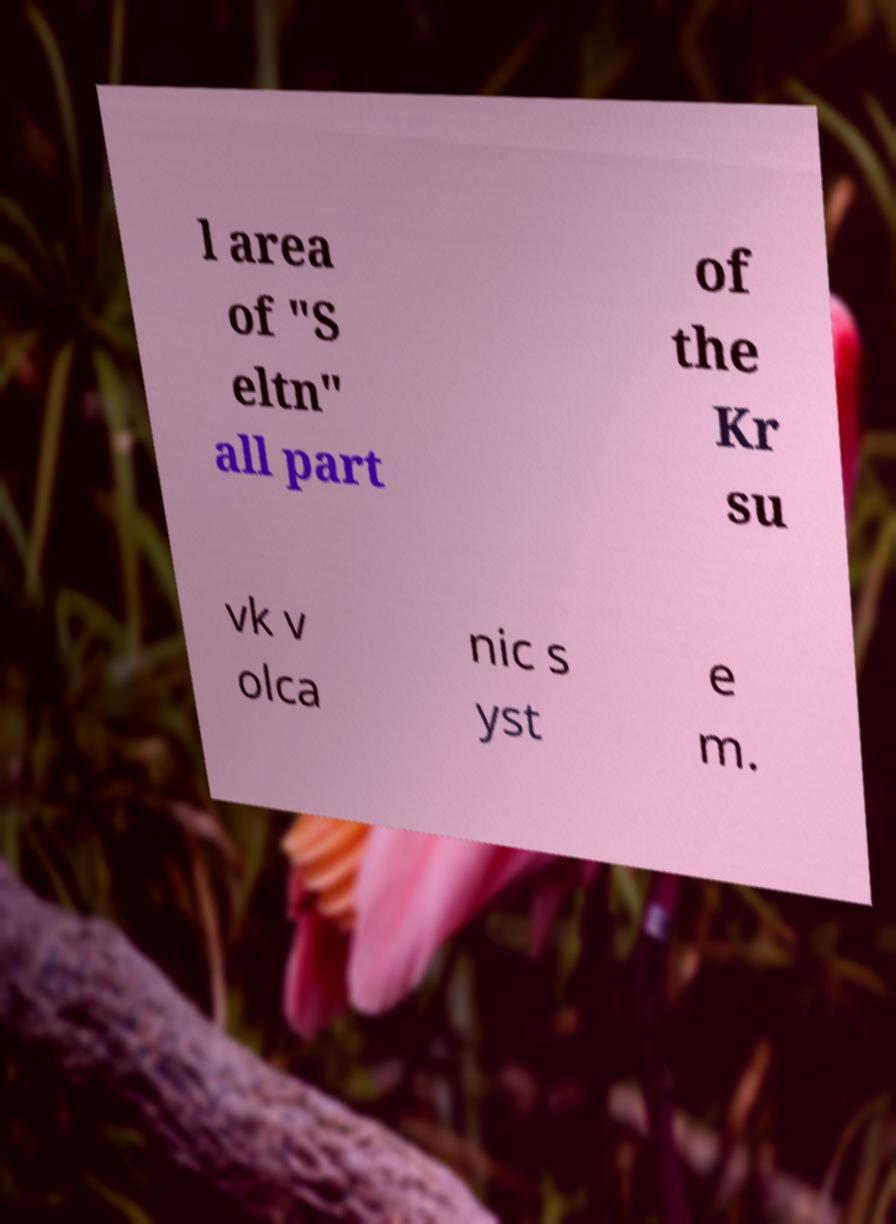For documentation purposes, I need the text within this image transcribed. Could you provide that? l area of "S eltn" all part of the Kr su vk v olca nic s yst e m. 